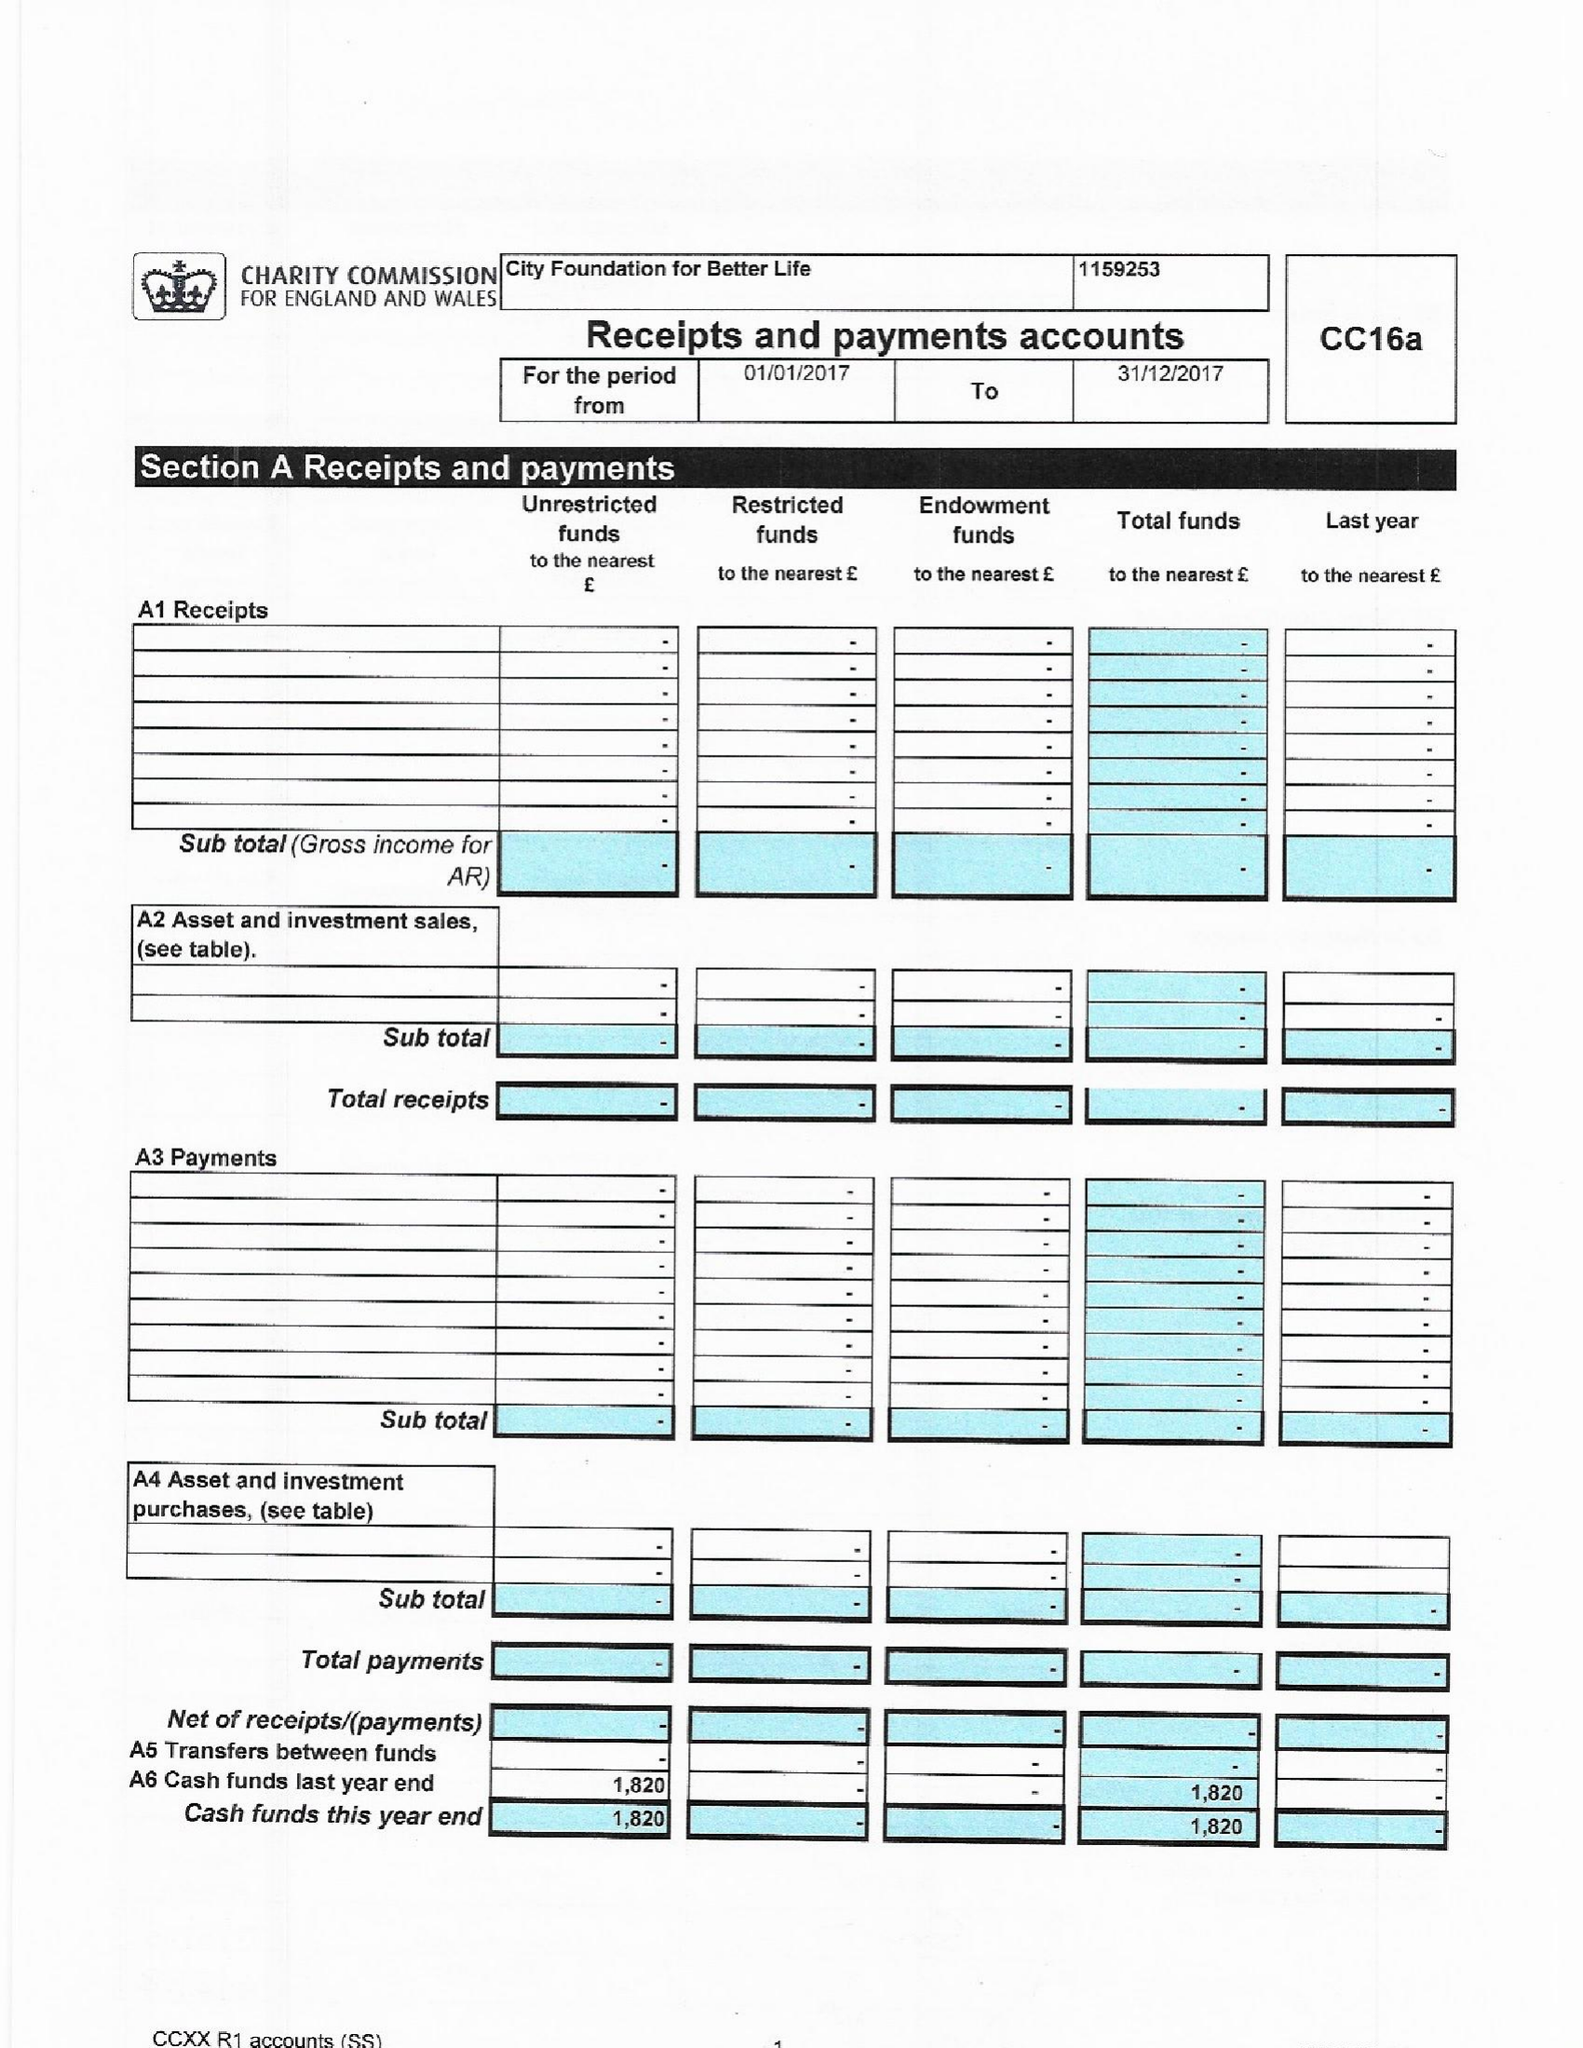What is the value for the address__street_line?
Answer the question using a single word or phrase. None 